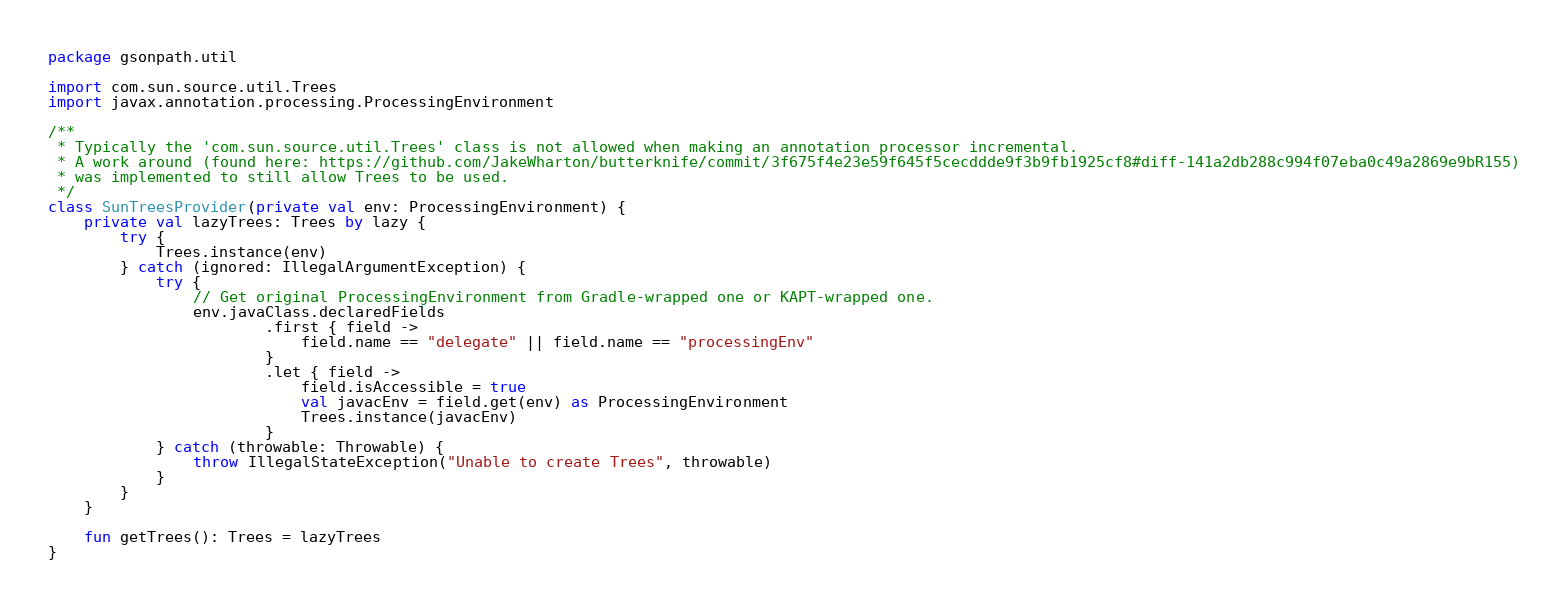Convert code to text. <code><loc_0><loc_0><loc_500><loc_500><_Kotlin_>package gsonpath.util

import com.sun.source.util.Trees
import javax.annotation.processing.ProcessingEnvironment

/**
 * Typically the 'com.sun.source.util.Trees' class is not allowed when making an annotation processor incremental.
 * A work around (found here: https://github.com/JakeWharton/butterknife/commit/3f675f4e23e59f645f5cecddde9f3b9fb1925cf8#diff-141a2db288c994f07eba0c49a2869e9bR155)
 * was implemented to still allow Trees to be used.
 */
class SunTreesProvider(private val env: ProcessingEnvironment) {
    private val lazyTrees: Trees by lazy {
        try {
            Trees.instance(env)
        } catch (ignored: IllegalArgumentException) {
            try {
                // Get original ProcessingEnvironment from Gradle-wrapped one or KAPT-wrapped one.
                env.javaClass.declaredFields
                        .first { field ->
                            field.name == "delegate" || field.name == "processingEnv"
                        }
                        .let { field ->
                            field.isAccessible = true
                            val javacEnv = field.get(env) as ProcessingEnvironment
                            Trees.instance(javacEnv)
                        }
            } catch (throwable: Throwable) {
                throw IllegalStateException("Unable to create Trees", throwable)
            }
        }
    }

    fun getTrees(): Trees = lazyTrees
}</code> 